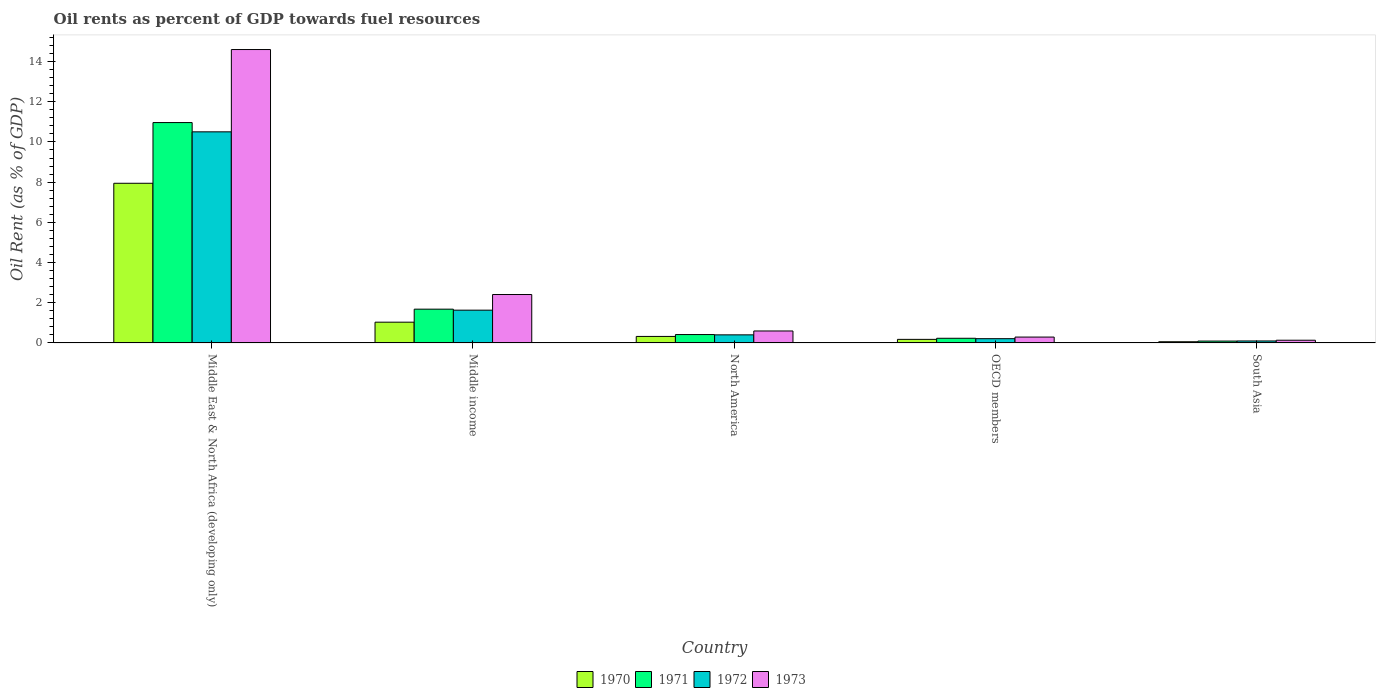How many different coloured bars are there?
Give a very brief answer. 4. Are the number of bars per tick equal to the number of legend labels?
Give a very brief answer. Yes. How many bars are there on the 5th tick from the left?
Your answer should be compact. 4. How many bars are there on the 2nd tick from the right?
Ensure brevity in your answer.  4. What is the label of the 1st group of bars from the left?
Your answer should be very brief. Middle East & North Africa (developing only). In how many cases, is the number of bars for a given country not equal to the number of legend labels?
Provide a short and direct response. 0. What is the oil rent in 1971 in Middle income?
Provide a short and direct response. 1.68. Across all countries, what is the maximum oil rent in 1971?
Make the answer very short. 10.96. Across all countries, what is the minimum oil rent in 1973?
Your response must be concise. 0.14. In which country was the oil rent in 1970 maximum?
Give a very brief answer. Middle East & North Africa (developing only). What is the total oil rent in 1973 in the graph?
Ensure brevity in your answer.  18.03. What is the difference between the oil rent in 1970 in OECD members and that in South Asia?
Offer a very short reply. 0.12. What is the difference between the oil rent in 1973 in Middle income and the oil rent in 1971 in Middle East & North Africa (developing only)?
Offer a very short reply. -8.55. What is the average oil rent in 1971 per country?
Your response must be concise. 2.68. What is the difference between the oil rent of/in 1970 and oil rent of/in 1971 in South Asia?
Provide a succinct answer. -0.03. What is the ratio of the oil rent in 1971 in Middle East & North Africa (developing only) to that in OECD members?
Ensure brevity in your answer.  47.15. Is the oil rent in 1973 in Middle East & North Africa (developing only) less than that in North America?
Give a very brief answer. No. What is the difference between the highest and the second highest oil rent in 1970?
Offer a terse response. -0.71. What is the difference between the highest and the lowest oil rent in 1970?
Offer a very short reply. 7.88. In how many countries, is the oil rent in 1973 greater than the average oil rent in 1973 taken over all countries?
Offer a very short reply. 1. Is it the case that in every country, the sum of the oil rent in 1973 and oil rent in 1972 is greater than the sum of oil rent in 1971 and oil rent in 1970?
Ensure brevity in your answer.  No. Are all the bars in the graph horizontal?
Your answer should be compact. No. What is the difference between two consecutive major ticks on the Y-axis?
Ensure brevity in your answer.  2. Are the values on the major ticks of Y-axis written in scientific E-notation?
Keep it short and to the point. No. How many legend labels are there?
Your answer should be compact. 4. How are the legend labels stacked?
Keep it short and to the point. Horizontal. What is the title of the graph?
Keep it short and to the point. Oil rents as percent of GDP towards fuel resources. Does "1997" appear as one of the legend labels in the graph?
Provide a short and direct response. No. What is the label or title of the X-axis?
Your response must be concise. Country. What is the label or title of the Y-axis?
Offer a terse response. Oil Rent (as % of GDP). What is the Oil Rent (as % of GDP) in 1970 in Middle East & North Africa (developing only)?
Ensure brevity in your answer.  7.94. What is the Oil Rent (as % of GDP) of 1971 in Middle East & North Africa (developing only)?
Provide a short and direct response. 10.96. What is the Oil Rent (as % of GDP) of 1972 in Middle East & North Africa (developing only)?
Keep it short and to the point. 10.5. What is the Oil Rent (as % of GDP) of 1973 in Middle East & North Africa (developing only)?
Offer a terse response. 14.6. What is the Oil Rent (as % of GDP) in 1970 in Middle income?
Offer a terse response. 1.03. What is the Oil Rent (as % of GDP) of 1971 in Middle income?
Offer a very short reply. 1.68. What is the Oil Rent (as % of GDP) in 1972 in Middle income?
Your answer should be very brief. 1.63. What is the Oil Rent (as % of GDP) of 1973 in Middle income?
Your answer should be compact. 2.41. What is the Oil Rent (as % of GDP) in 1970 in North America?
Ensure brevity in your answer.  0.32. What is the Oil Rent (as % of GDP) in 1971 in North America?
Your answer should be very brief. 0.42. What is the Oil Rent (as % of GDP) in 1972 in North America?
Offer a terse response. 0.4. What is the Oil Rent (as % of GDP) of 1973 in North America?
Offer a terse response. 0.6. What is the Oil Rent (as % of GDP) in 1970 in OECD members?
Your answer should be very brief. 0.18. What is the Oil Rent (as % of GDP) in 1971 in OECD members?
Your answer should be compact. 0.23. What is the Oil Rent (as % of GDP) of 1972 in OECD members?
Provide a short and direct response. 0.21. What is the Oil Rent (as % of GDP) in 1973 in OECD members?
Your response must be concise. 0.29. What is the Oil Rent (as % of GDP) in 1970 in South Asia?
Make the answer very short. 0.06. What is the Oil Rent (as % of GDP) in 1971 in South Asia?
Your answer should be very brief. 0.09. What is the Oil Rent (as % of GDP) in 1972 in South Asia?
Your answer should be compact. 0.1. What is the Oil Rent (as % of GDP) in 1973 in South Asia?
Your answer should be very brief. 0.14. Across all countries, what is the maximum Oil Rent (as % of GDP) in 1970?
Offer a terse response. 7.94. Across all countries, what is the maximum Oil Rent (as % of GDP) in 1971?
Keep it short and to the point. 10.96. Across all countries, what is the maximum Oil Rent (as % of GDP) of 1972?
Offer a terse response. 10.5. Across all countries, what is the maximum Oil Rent (as % of GDP) in 1973?
Keep it short and to the point. 14.6. Across all countries, what is the minimum Oil Rent (as % of GDP) of 1970?
Offer a very short reply. 0.06. Across all countries, what is the minimum Oil Rent (as % of GDP) in 1971?
Give a very brief answer. 0.09. Across all countries, what is the minimum Oil Rent (as % of GDP) of 1972?
Give a very brief answer. 0.1. Across all countries, what is the minimum Oil Rent (as % of GDP) of 1973?
Give a very brief answer. 0.14. What is the total Oil Rent (as % of GDP) of 1970 in the graph?
Offer a terse response. 9.54. What is the total Oil Rent (as % of GDP) in 1971 in the graph?
Make the answer very short. 13.39. What is the total Oil Rent (as % of GDP) of 1972 in the graph?
Offer a terse response. 12.85. What is the total Oil Rent (as % of GDP) in 1973 in the graph?
Keep it short and to the point. 18.03. What is the difference between the Oil Rent (as % of GDP) in 1970 in Middle East & North Africa (developing only) and that in Middle income?
Keep it short and to the point. 6.91. What is the difference between the Oil Rent (as % of GDP) of 1971 in Middle East & North Africa (developing only) and that in Middle income?
Provide a short and direct response. 9.28. What is the difference between the Oil Rent (as % of GDP) of 1972 in Middle East & North Africa (developing only) and that in Middle income?
Your answer should be very brief. 8.87. What is the difference between the Oil Rent (as % of GDP) in 1973 in Middle East & North Africa (developing only) and that in Middle income?
Give a very brief answer. 12.19. What is the difference between the Oil Rent (as % of GDP) in 1970 in Middle East & North Africa (developing only) and that in North America?
Offer a very short reply. 7.62. What is the difference between the Oil Rent (as % of GDP) in 1971 in Middle East & North Africa (developing only) and that in North America?
Ensure brevity in your answer.  10.55. What is the difference between the Oil Rent (as % of GDP) in 1972 in Middle East & North Africa (developing only) and that in North America?
Provide a short and direct response. 10.1. What is the difference between the Oil Rent (as % of GDP) in 1973 in Middle East & North Africa (developing only) and that in North America?
Ensure brevity in your answer.  14. What is the difference between the Oil Rent (as % of GDP) in 1970 in Middle East & North Africa (developing only) and that in OECD members?
Your response must be concise. 7.77. What is the difference between the Oil Rent (as % of GDP) in 1971 in Middle East & North Africa (developing only) and that in OECD members?
Offer a terse response. 10.73. What is the difference between the Oil Rent (as % of GDP) in 1972 in Middle East & North Africa (developing only) and that in OECD members?
Provide a succinct answer. 10.29. What is the difference between the Oil Rent (as % of GDP) of 1973 in Middle East & North Africa (developing only) and that in OECD members?
Provide a short and direct response. 14.3. What is the difference between the Oil Rent (as % of GDP) in 1970 in Middle East & North Africa (developing only) and that in South Asia?
Ensure brevity in your answer.  7.88. What is the difference between the Oil Rent (as % of GDP) of 1971 in Middle East & North Africa (developing only) and that in South Asia?
Provide a succinct answer. 10.87. What is the difference between the Oil Rent (as % of GDP) in 1972 in Middle East & North Africa (developing only) and that in South Asia?
Ensure brevity in your answer.  10.4. What is the difference between the Oil Rent (as % of GDP) of 1973 in Middle East & North Africa (developing only) and that in South Asia?
Offer a terse response. 14.46. What is the difference between the Oil Rent (as % of GDP) of 1970 in Middle income and that in North America?
Your answer should be very brief. 0.71. What is the difference between the Oil Rent (as % of GDP) of 1971 in Middle income and that in North America?
Your response must be concise. 1.26. What is the difference between the Oil Rent (as % of GDP) of 1972 in Middle income and that in North America?
Provide a succinct answer. 1.23. What is the difference between the Oil Rent (as % of GDP) in 1973 in Middle income and that in North America?
Your response must be concise. 1.81. What is the difference between the Oil Rent (as % of GDP) of 1970 in Middle income and that in OECD members?
Provide a short and direct response. 0.85. What is the difference between the Oil Rent (as % of GDP) of 1971 in Middle income and that in OECD members?
Offer a very short reply. 1.45. What is the difference between the Oil Rent (as % of GDP) in 1972 in Middle income and that in OECD members?
Your answer should be very brief. 1.42. What is the difference between the Oil Rent (as % of GDP) in 1973 in Middle income and that in OECD members?
Provide a succinct answer. 2.12. What is the difference between the Oil Rent (as % of GDP) in 1970 in Middle income and that in South Asia?
Keep it short and to the point. 0.97. What is the difference between the Oil Rent (as % of GDP) in 1971 in Middle income and that in South Asia?
Keep it short and to the point. 1.59. What is the difference between the Oil Rent (as % of GDP) of 1972 in Middle income and that in South Asia?
Keep it short and to the point. 1.53. What is the difference between the Oil Rent (as % of GDP) in 1973 in Middle income and that in South Asia?
Provide a succinct answer. 2.27. What is the difference between the Oil Rent (as % of GDP) of 1970 in North America and that in OECD members?
Your answer should be very brief. 0.15. What is the difference between the Oil Rent (as % of GDP) of 1971 in North America and that in OECD members?
Give a very brief answer. 0.18. What is the difference between the Oil Rent (as % of GDP) in 1972 in North America and that in OECD members?
Offer a terse response. 0.19. What is the difference between the Oil Rent (as % of GDP) of 1973 in North America and that in OECD members?
Ensure brevity in your answer.  0.3. What is the difference between the Oil Rent (as % of GDP) in 1970 in North America and that in South Asia?
Offer a terse response. 0.26. What is the difference between the Oil Rent (as % of GDP) of 1971 in North America and that in South Asia?
Make the answer very short. 0.32. What is the difference between the Oil Rent (as % of GDP) in 1972 in North America and that in South Asia?
Your response must be concise. 0.3. What is the difference between the Oil Rent (as % of GDP) in 1973 in North America and that in South Asia?
Your answer should be compact. 0.46. What is the difference between the Oil Rent (as % of GDP) in 1970 in OECD members and that in South Asia?
Your answer should be compact. 0.12. What is the difference between the Oil Rent (as % of GDP) of 1971 in OECD members and that in South Asia?
Your response must be concise. 0.14. What is the difference between the Oil Rent (as % of GDP) of 1972 in OECD members and that in South Asia?
Give a very brief answer. 0.11. What is the difference between the Oil Rent (as % of GDP) in 1973 in OECD members and that in South Asia?
Your response must be concise. 0.16. What is the difference between the Oil Rent (as % of GDP) in 1970 in Middle East & North Africa (developing only) and the Oil Rent (as % of GDP) in 1971 in Middle income?
Provide a short and direct response. 6.26. What is the difference between the Oil Rent (as % of GDP) in 1970 in Middle East & North Africa (developing only) and the Oil Rent (as % of GDP) in 1972 in Middle income?
Your answer should be compact. 6.31. What is the difference between the Oil Rent (as % of GDP) in 1970 in Middle East & North Africa (developing only) and the Oil Rent (as % of GDP) in 1973 in Middle income?
Your answer should be compact. 5.53. What is the difference between the Oil Rent (as % of GDP) of 1971 in Middle East & North Africa (developing only) and the Oil Rent (as % of GDP) of 1972 in Middle income?
Provide a succinct answer. 9.33. What is the difference between the Oil Rent (as % of GDP) of 1971 in Middle East & North Africa (developing only) and the Oil Rent (as % of GDP) of 1973 in Middle income?
Make the answer very short. 8.55. What is the difference between the Oil Rent (as % of GDP) in 1972 in Middle East & North Africa (developing only) and the Oil Rent (as % of GDP) in 1973 in Middle income?
Your answer should be compact. 8.09. What is the difference between the Oil Rent (as % of GDP) in 1970 in Middle East & North Africa (developing only) and the Oil Rent (as % of GDP) in 1971 in North America?
Give a very brief answer. 7.53. What is the difference between the Oil Rent (as % of GDP) in 1970 in Middle East & North Africa (developing only) and the Oil Rent (as % of GDP) in 1972 in North America?
Provide a succinct answer. 7.54. What is the difference between the Oil Rent (as % of GDP) in 1970 in Middle East & North Africa (developing only) and the Oil Rent (as % of GDP) in 1973 in North America?
Offer a very short reply. 7.35. What is the difference between the Oil Rent (as % of GDP) of 1971 in Middle East & North Africa (developing only) and the Oil Rent (as % of GDP) of 1972 in North America?
Make the answer very short. 10.56. What is the difference between the Oil Rent (as % of GDP) in 1971 in Middle East & North Africa (developing only) and the Oil Rent (as % of GDP) in 1973 in North America?
Offer a very short reply. 10.37. What is the difference between the Oil Rent (as % of GDP) of 1972 in Middle East & North Africa (developing only) and the Oil Rent (as % of GDP) of 1973 in North America?
Ensure brevity in your answer.  9.91. What is the difference between the Oil Rent (as % of GDP) in 1970 in Middle East & North Africa (developing only) and the Oil Rent (as % of GDP) in 1971 in OECD members?
Your answer should be compact. 7.71. What is the difference between the Oil Rent (as % of GDP) in 1970 in Middle East & North Africa (developing only) and the Oil Rent (as % of GDP) in 1972 in OECD members?
Offer a very short reply. 7.73. What is the difference between the Oil Rent (as % of GDP) of 1970 in Middle East & North Africa (developing only) and the Oil Rent (as % of GDP) of 1973 in OECD members?
Make the answer very short. 7.65. What is the difference between the Oil Rent (as % of GDP) of 1971 in Middle East & North Africa (developing only) and the Oil Rent (as % of GDP) of 1972 in OECD members?
Make the answer very short. 10.75. What is the difference between the Oil Rent (as % of GDP) in 1971 in Middle East & North Africa (developing only) and the Oil Rent (as % of GDP) in 1973 in OECD members?
Your answer should be compact. 10.67. What is the difference between the Oil Rent (as % of GDP) of 1972 in Middle East & North Africa (developing only) and the Oil Rent (as % of GDP) of 1973 in OECD members?
Offer a very short reply. 10.21. What is the difference between the Oil Rent (as % of GDP) in 1970 in Middle East & North Africa (developing only) and the Oil Rent (as % of GDP) in 1971 in South Asia?
Make the answer very short. 7.85. What is the difference between the Oil Rent (as % of GDP) of 1970 in Middle East & North Africa (developing only) and the Oil Rent (as % of GDP) of 1972 in South Asia?
Your answer should be very brief. 7.84. What is the difference between the Oil Rent (as % of GDP) of 1970 in Middle East & North Africa (developing only) and the Oil Rent (as % of GDP) of 1973 in South Asia?
Offer a very short reply. 7.81. What is the difference between the Oil Rent (as % of GDP) in 1971 in Middle East & North Africa (developing only) and the Oil Rent (as % of GDP) in 1972 in South Asia?
Your answer should be very brief. 10.86. What is the difference between the Oil Rent (as % of GDP) of 1971 in Middle East & North Africa (developing only) and the Oil Rent (as % of GDP) of 1973 in South Asia?
Offer a terse response. 10.83. What is the difference between the Oil Rent (as % of GDP) in 1972 in Middle East & North Africa (developing only) and the Oil Rent (as % of GDP) in 1973 in South Asia?
Your answer should be compact. 10.37. What is the difference between the Oil Rent (as % of GDP) in 1970 in Middle income and the Oil Rent (as % of GDP) in 1971 in North America?
Give a very brief answer. 0.61. What is the difference between the Oil Rent (as % of GDP) of 1970 in Middle income and the Oil Rent (as % of GDP) of 1972 in North America?
Offer a very short reply. 0.63. What is the difference between the Oil Rent (as % of GDP) in 1970 in Middle income and the Oil Rent (as % of GDP) in 1973 in North America?
Make the answer very short. 0.44. What is the difference between the Oil Rent (as % of GDP) in 1971 in Middle income and the Oil Rent (as % of GDP) in 1972 in North America?
Keep it short and to the point. 1.28. What is the difference between the Oil Rent (as % of GDP) in 1971 in Middle income and the Oil Rent (as % of GDP) in 1973 in North America?
Provide a succinct answer. 1.09. What is the difference between the Oil Rent (as % of GDP) in 1972 in Middle income and the Oil Rent (as % of GDP) in 1973 in North America?
Keep it short and to the point. 1.04. What is the difference between the Oil Rent (as % of GDP) in 1970 in Middle income and the Oil Rent (as % of GDP) in 1971 in OECD members?
Offer a very short reply. 0.8. What is the difference between the Oil Rent (as % of GDP) in 1970 in Middle income and the Oil Rent (as % of GDP) in 1972 in OECD members?
Give a very brief answer. 0.82. What is the difference between the Oil Rent (as % of GDP) of 1970 in Middle income and the Oil Rent (as % of GDP) of 1973 in OECD members?
Ensure brevity in your answer.  0.74. What is the difference between the Oil Rent (as % of GDP) of 1971 in Middle income and the Oil Rent (as % of GDP) of 1972 in OECD members?
Ensure brevity in your answer.  1.47. What is the difference between the Oil Rent (as % of GDP) of 1971 in Middle income and the Oil Rent (as % of GDP) of 1973 in OECD members?
Provide a succinct answer. 1.39. What is the difference between the Oil Rent (as % of GDP) of 1972 in Middle income and the Oil Rent (as % of GDP) of 1973 in OECD members?
Offer a terse response. 1.34. What is the difference between the Oil Rent (as % of GDP) of 1970 in Middle income and the Oil Rent (as % of GDP) of 1971 in South Asia?
Ensure brevity in your answer.  0.94. What is the difference between the Oil Rent (as % of GDP) of 1970 in Middle income and the Oil Rent (as % of GDP) of 1972 in South Asia?
Give a very brief answer. 0.93. What is the difference between the Oil Rent (as % of GDP) in 1970 in Middle income and the Oil Rent (as % of GDP) in 1973 in South Asia?
Your response must be concise. 0.9. What is the difference between the Oil Rent (as % of GDP) in 1971 in Middle income and the Oil Rent (as % of GDP) in 1972 in South Asia?
Provide a short and direct response. 1.58. What is the difference between the Oil Rent (as % of GDP) of 1971 in Middle income and the Oil Rent (as % of GDP) of 1973 in South Asia?
Keep it short and to the point. 1.55. What is the difference between the Oil Rent (as % of GDP) in 1972 in Middle income and the Oil Rent (as % of GDP) in 1973 in South Asia?
Your answer should be compact. 1.5. What is the difference between the Oil Rent (as % of GDP) of 1970 in North America and the Oil Rent (as % of GDP) of 1971 in OECD members?
Your answer should be very brief. 0.09. What is the difference between the Oil Rent (as % of GDP) of 1970 in North America and the Oil Rent (as % of GDP) of 1972 in OECD members?
Your answer should be very brief. 0.11. What is the difference between the Oil Rent (as % of GDP) in 1970 in North America and the Oil Rent (as % of GDP) in 1973 in OECD members?
Your response must be concise. 0.03. What is the difference between the Oil Rent (as % of GDP) in 1971 in North America and the Oil Rent (as % of GDP) in 1972 in OECD members?
Make the answer very short. 0.21. What is the difference between the Oil Rent (as % of GDP) in 1971 in North America and the Oil Rent (as % of GDP) in 1973 in OECD members?
Your answer should be very brief. 0.13. What is the difference between the Oil Rent (as % of GDP) in 1972 in North America and the Oil Rent (as % of GDP) in 1973 in OECD members?
Provide a succinct answer. 0.11. What is the difference between the Oil Rent (as % of GDP) in 1970 in North America and the Oil Rent (as % of GDP) in 1971 in South Asia?
Your answer should be very brief. 0.23. What is the difference between the Oil Rent (as % of GDP) of 1970 in North America and the Oil Rent (as % of GDP) of 1972 in South Asia?
Ensure brevity in your answer.  0.23. What is the difference between the Oil Rent (as % of GDP) in 1970 in North America and the Oil Rent (as % of GDP) in 1973 in South Asia?
Provide a short and direct response. 0.19. What is the difference between the Oil Rent (as % of GDP) in 1971 in North America and the Oil Rent (as % of GDP) in 1972 in South Asia?
Provide a succinct answer. 0.32. What is the difference between the Oil Rent (as % of GDP) in 1971 in North America and the Oil Rent (as % of GDP) in 1973 in South Asia?
Provide a short and direct response. 0.28. What is the difference between the Oil Rent (as % of GDP) in 1972 in North America and the Oil Rent (as % of GDP) in 1973 in South Asia?
Your response must be concise. 0.27. What is the difference between the Oil Rent (as % of GDP) in 1970 in OECD members and the Oil Rent (as % of GDP) in 1971 in South Asia?
Ensure brevity in your answer.  0.08. What is the difference between the Oil Rent (as % of GDP) in 1970 in OECD members and the Oil Rent (as % of GDP) in 1972 in South Asia?
Provide a succinct answer. 0.08. What is the difference between the Oil Rent (as % of GDP) of 1970 in OECD members and the Oil Rent (as % of GDP) of 1973 in South Asia?
Your response must be concise. 0.04. What is the difference between the Oil Rent (as % of GDP) of 1971 in OECD members and the Oil Rent (as % of GDP) of 1972 in South Asia?
Make the answer very short. 0.13. What is the difference between the Oil Rent (as % of GDP) in 1971 in OECD members and the Oil Rent (as % of GDP) in 1973 in South Asia?
Provide a succinct answer. 0.1. What is the difference between the Oil Rent (as % of GDP) of 1972 in OECD members and the Oil Rent (as % of GDP) of 1973 in South Asia?
Your answer should be very brief. 0.08. What is the average Oil Rent (as % of GDP) of 1970 per country?
Your answer should be compact. 1.91. What is the average Oil Rent (as % of GDP) in 1971 per country?
Offer a very short reply. 2.68. What is the average Oil Rent (as % of GDP) in 1972 per country?
Offer a very short reply. 2.57. What is the average Oil Rent (as % of GDP) in 1973 per country?
Give a very brief answer. 3.61. What is the difference between the Oil Rent (as % of GDP) of 1970 and Oil Rent (as % of GDP) of 1971 in Middle East & North Africa (developing only)?
Your response must be concise. -3.02. What is the difference between the Oil Rent (as % of GDP) in 1970 and Oil Rent (as % of GDP) in 1972 in Middle East & North Africa (developing only)?
Give a very brief answer. -2.56. What is the difference between the Oil Rent (as % of GDP) of 1970 and Oil Rent (as % of GDP) of 1973 in Middle East & North Africa (developing only)?
Provide a short and direct response. -6.65. What is the difference between the Oil Rent (as % of GDP) in 1971 and Oil Rent (as % of GDP) in 1972 in Middle East & North Africa (developing only)?
Offer a very short reply. 0.46. What is the difference between the Oil Rent (as % of GDP) in 1971 and Oil Rent (as % of GDP) in 1973 in Middle East & North Africa (developing only)?
Offer a terse response. -3.63. What is the difference between the Oil Rent (as % of GDP) in 1972 and Oil Rent (as % of GDP) in 1973 in Middle East & North Africa (developing only)?
Offer a very short reply. -4.09. What is the difference between the Oil Rent (as % of GDP) of 1970 and Oil Rent (as % of GDP) of 1971 in Middle income?
Ensure brevity in your answer.  -0.65. What is the difference between the Oil Rent (as % of GDP) in 1970 and Oil Rent (as % of GDP) in 1972 in Middle income?
Offer a terse response. -0.6. What is the difference between the Oil Rent (as % of GDP) in 1970 and Oil Rent (as % of GDP) in 1973 in Middle income?
Provide a succinct answer. -1.38. What is the difference between the Oil Rent (as % of GDP) of 1971 and Oil Rent (as % of GDP) of 1972 in Middle income?
Make the answer very short. 0.05. What is the difference between the Oil Rent (as % of GDP) in 1971 and Oil Rent (as % of GDP) in 1973 in Middle income?
Your answer should be very brief. -0.73. What is the difference between the Oil Rent (as % of GDP) of 1972 and Oil Rent (as % of GDP) of 1973 in Middle income?
Your answer should be very brief. -0.78. What is the difference between the Oil Rent (as % of GDP) of 1970 and Oil Rent (as % of GDP) of 1971 in North America?
Offer a terse response. -0.09. What is the difference between the Oil Rent (as % of GDP) of 1970 and Oil Rent (as % of GDP) of 1972 in North America?
Make the answer very short. -0.08. What is the difference between the Oil Rent (as % of GDP) in 1970 and Oil Rent (as % of GDP) in 1973 in North America?
Make the answer very short. -0.27. What is the difference between the Oil Rent (as % of GDP) of 1971 and Oil Rent (as % of GDP) of 1972 in North America?
Ensure brevity in your answer.  0.02. What is the difference between the Oil Rent (as % of GDP) in 1971 and Oil Rent (as % of GDP) in 1973 in North America?
Provide a short and direct response. -0.18. What is the difference between the Oil Rent (as % of GDP) of 1972 and Oil Rent (as % of GDP) of 1973 in North America?
Ensure brevity in your answer.  -0.19. What is the difference between the Oil Rent (as % of GDP) of 1970 and Oil Rent (as % of GDP) of 1971 in OECD members?
Offer a very short reply. -0.05. What is the difference between the Oil Rent (as % of GDP) in 1970 and Oil Rent (as % of GDP) in 1972 in OECD members?
Provide a succinct answer. -0.03. What is the difference between the Oil Rent (as % of GDP) of 1970 and Oil Rent (as % of GDP) of 1973 in OECD members?
Make the answer very short. -0.11. What is the difference between the Oil Rent (as % of GDP) of 1971 and Oil Rent (as % of GDP) of 1972 in OECD members?
Your response must be concise. 0.02. What is the difference between the Oil Rent (as % of GDP) of 1971 and Oil Rent (as % of GDP) of 1973 in OECD members?
Offer a terse response. -0.06. What is the difference between the Oil Rent (as % of GDP) of 1972 and Oil Rent (as % of GDP) of 1973 in OECD members?
Provide a succinct answer. -0.08. What is the difference between the Oil Rent (as % of GDP) in 1970 and Oil Rent (as % of GDP) in 1971 in South Asia?
Your answer should be very brief. -0.03. What is the difference between the Oil Rent (as % of GDP) in 1970 and Oil Rent (as % of GDP) in 1972 in South Asia?
Your response must be concise. -0.04. What is the difference between the Oil Rent (as % of GDP) in 1970 and Oil Rent (as % of GDP) in 1973 in South Asia?
Ensure brevity in your answer.  -0.08. What is the difference between the Oil Rent (as % of GDP) of 1971 and Oil Rent (as % of GDP) of 1972 in South Asia?
Provide a succinct answer. -0.01. What is the difference between the Oil Rent (as % of GDP) of 1971 and Oil Rent (as % of GDP) of 1973 in South Asia?
Give a very brief answer. -0.04. What is the difference between the Oil Rent (as % of GDP) in 1972 and Oil Rent (as % of GDP) in 1973 in South Asia?
Your answer should be very brief. -0.04. What is the ratio of the Oil Rent (as % of GDP) in 1970 in Middle East & North Africa (developing only) to that in Middle income?
Provide a succinct answer. 7.69. What is the ratio of the Oil Rent (as % of GDP) in 1971 in Middle East & North Africa (developing only) to that in Middle income?
Offer a very short reply. 6.52. What is the ratio of the Oil Rent (as % of GDP) of 1972 in Middle East & North Africa (developing only) to that in Middle income?
Offer a very short reply. 6.44. What is the ratio of the Oil Rent (as % of GDP) of 1973 in Middle East & North Africa (developing only) to that in Middle income?
Your answer should be very brief. 6.06. What is the ratio of the Oil Rent (as % of GDP) of 1970 in Middle East & North Africa (developing only) to that in North America?
Provide a short and direct response. 24.54. What is the ratio of the Oil Rent (as % of GDP) in 1971 in Middle East & North Africa (developing only) to that in North America?
Make the answer very short. 26.26. What is the ratio of the Oil Rent (as % of GDP) in 1972 in Middle East & North Africa (developing only) to that in North America?
Ensure brevity in your answer.  26.11. What is the ratio of the Oil Rent (as % of GDP) in 1973 in Middle East & North Africa (developing only) to that in North America?
Offer a very short reply. 24.53. What is the ratio of the Oil Rent (as % of GDP) of 1970 in Middle East & North Africa (developing only) to that in OECD members?
Offer a very short reply. 44.68. What is the ratio of the Oil Rent (as % of GDP) in 1971 in Middle East & North Africa (developing only) to that in OECD members?
Keep it short and to the point. 47.15. What is the ratio of the Oil Rent (as % of GDP) in 1972 in Middle East & North Africa (developing only) to that in OECD members?
Offer a terse response. 49.49. What is the ratio of the Oil Rent (as % of GDP) of 1973 in Middle East & North Africa (developing only) to that in OECD members?
Your answer should be very brief. 50.04. What is the ratio of the Oil Rent (as % of GDP) of 1970 in Middle East & North Africa (developing only) to that in South Asia?
Keep it short and to the point. 132.59. What is the ratio of the Oil Rent (as % of GDP) in 1971 in Middle East & North Africa (developing only) to that in South Asia?
Keep it short and to the point. 117.69. What is the ratio of the Oil Rent (as % of GDP) in 1972 in Middle East & North Africa (developing only) to that in South Asia?
Ensure brevity in your answer.  106.59. What is the ratio of the Oil Rent (as % of GDP) in 1973 in Middle East & North Africa (developing only) to that in South Asia?
Offer a very short reply. 108.09. What is the ratio of the Oil Rent (as % of GDP) of 1970 in Middle income to that in North America?
Your answer should be very brief. 3.19. What is the ratio of the Oil Rent (as % of GDP) in 1971 in Middle income to that in North America?
Your response must be concise. 4.03. What is the ratio of the Oil Rent (as % of GDP) of 1972 in Middle income to that in North America?
Provide a succinct answer. 4.05. What is the ratio of the Oil Rent (as % of GDP) of 1973 in Middle income to that in North America?
Keep it short and to the point. 4.05. What is the ratio of the Oil Rent (as % of GDP) of 1970 in Middle income to that in OECD members?
Your response must be concise. 5.81. What is the ratio of the Oil Rent (as % of GDP) in 1971 in Middle income to that in OECD members?
Your answer should be compact. 7.23. What is the ratio of the Oil Rent (as % of GDP) of 1972 in Middle income to that in OECD members?
Your answer should be compact. 7.68. What is the ratio of the Oil Rent (as % of GDP) of 1973 in Middle income to that in OECD members?
Ensure brevity in your answer.  8.26. What is the ratio of the Oil Rent (as % of GDP) in 1970 in Middle income to that in South Asia?
Your answer should be compact. 17.23. What is the ratio of the Oil Rent (as % of GDP) of 1971 in Middle income to that in South Asia?
Ensure brevity in your answer.  18.04. What is the ratio of the Oil Rent (as % of GDP) of 1972 in Middle income to that in South Asia?
Provide a succinct answer. 16.55. What is the ratio of the Oil Rent (as % of GDP) in 1973 in Middle income to that in South Asia?
Give a very brief answer. 17.84. What is the ratio of the Oil Rent (as % of GDP) of 1970 in North America to that in OECD members?
Keep it short and to the point. 1.82. What is the ratio of the Oil Rent (as % of GDP) in 1971 in North America to that in OECD members?
Your response must be concise. 1.8. What is the ratio of the Oil Rent (as % of GDP) in 1972 in North America to that in OECD members?
Make the answer very short. 1.9. What is the ratio of the Oil Rent (as % of GDP) in 1973 in North America to that in OECD members?
Your response must be concise. 2.04. What is the ratio of the Oil Rent (as % of GDP) of 1970 in North America to that in South Asia?
Your answer should be very brief. 5.4. What is the ratio of the Oil Rent (as % of GDP) of 1971 in North America to that in South Asia?
Offer a terse response. 4.48. What is the ratio of the Oil Rent (as % of GDP) in 1972 in North America to that in South Asia?
Ensure brevity in your answer.  4.08. What is the ratio of the Oil Rent (as % of GDP) in 1973 in North America to that in South Asia?
Your answer should be very brief. 4.41. What is the ratio of the Oil Rent (as % of GDP) of 1970 in OECD members to that in South Asia?
Your answer should be very brief. 2.97. What is the ratio of the Oil Rent (as % of GDP) of 1971 in OECD members to that in South Asia?
Provide a succinct answer. 2.5. What is the ratio of the Oil Rent (as % of GDP) in 1972 in OECD members to that in South Asia?
Ensure brevity in your answer.  2.15. What is the ratio of the Oil Rent (as % of GDP) in 1973 in OECD members to that in South Asia?
Ensure brevity in your answer.  2.16. What is the difference between the highest and the second highest Oil Rent (as % of GDP) of 1970?
Offer a terse response. 6.91. What is the difference between the highest and the second highest Oil Rent (as % of GDP) of 1971?
Keep it short and to the point. 9.28. What is the difference between the highest and the second highest Oil Rent (as % of GDP) in 1972?
Offer a very short reply. 8.87. What is the difference between the highest and the second highest Oil Rent (as % of GDP) of 1973?
Ensure brevity in your answer.  12.19. What is the difference between the highest and the lowest Oil Rent (as % of GDP) of 1970?
Your answer should be compact. 7.88. What is the difference between the highest and the lowest Oil Rent (as % of GDP) of 1971?
Ensure brevity in your answer.  10.87. What is the difference between the highest and the lowest Oil Rent (as % of GDP) of 1972?
Your response must be concise. 10.4. What is the difference between the highest and the lowest Oil Rent (as % of GDP) of 1973?
Your response must be concise. 14.46. 